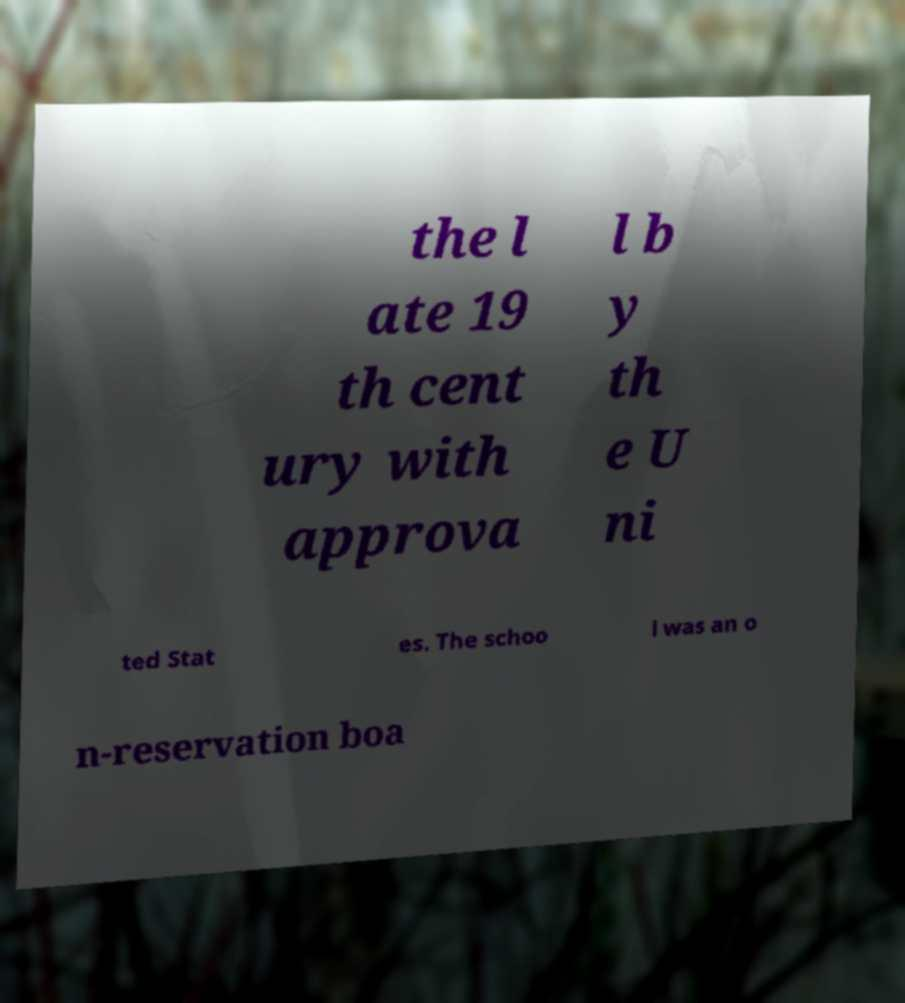Can you accurately transcribe the text from the provided image for me? the l ate 19 th cent ury with approva l b y th e U ni ted Stat es. The schoo l was an o n-reservation boa 